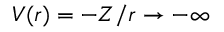Convert formula to latex. <formula><loc_0><loc_0><loc_500><loc_500>V ( r ) = - Z / r \to - \infty</formula> 